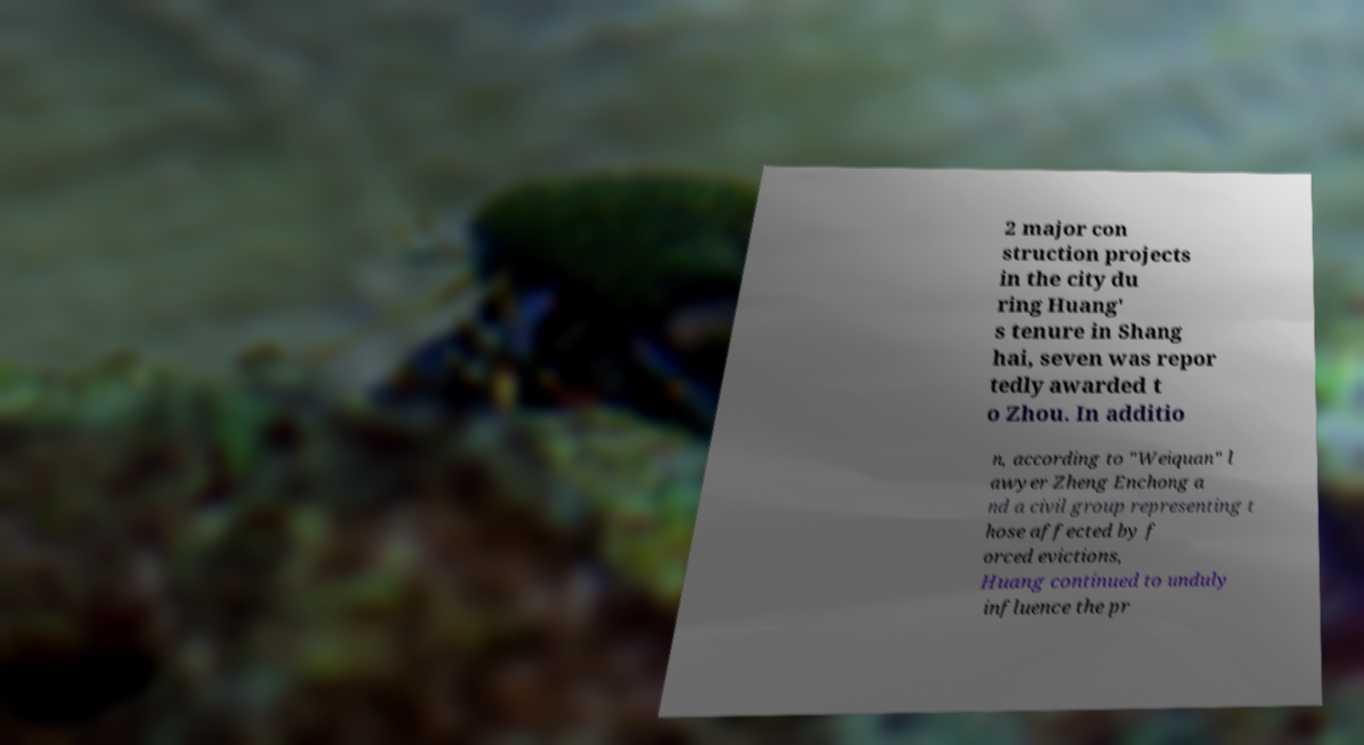Can you read and provide the text displayed in the image?This photo seems to have some interesting text. Can you extract and type it out for me? 2 major con struction projects in the city du ring Huang' s tenure in Shang hai, seven was repor tedly awarded t o Zhou. In additio n, according to "Weiquan" l awyer Zheng Enchong a nd a civil group representing t hose affected by f orced evictions, Huang continued to unduly influence the pr 